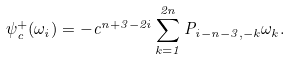<formula> <loc_0><loc_0><loc_500><loc_500>\psi _ { c } ^ { + } ( \omega _ { i } ) = - c ^ { n + 3 - 2 i } \sum _ { k = 1 } ^ { 2 n } P _ { i - n - 3 , - k } \omega _ { k } .</formula> 